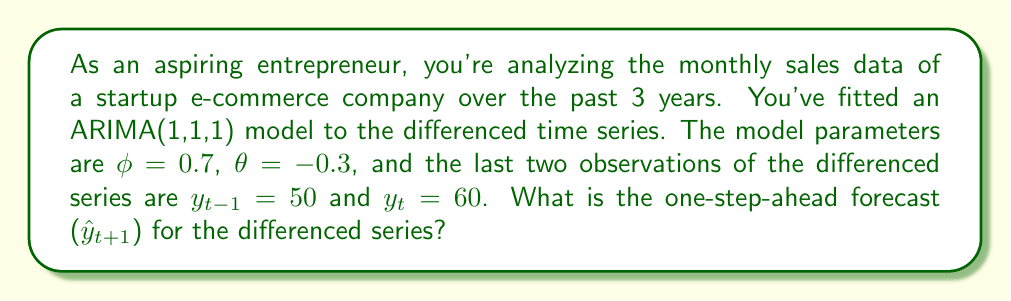Teach me how to tackle this problem. Let's approach this step-by-step:

1) The ARIMA(1,1,1) model for the differenced series can be written as:

   $$(1 - \phi B)(1 - B)Y_t = (1 + \theta B)\epsilon_t$$

   where $B$ is the backshift operator.

2) Expanding this, we get:

   $$Y_t - Y_{t-1} - \phi(Y_{t-1} - Y_{t-2}) = \epsilon_t + \theta\epsilon_{t-1}$$

3) Rearranging for forecasting:

   $$Y_t = Y_{t-1} + \phi(Y_{t-1} - Y_{t-2}) + \epsilon_t + \theta\epsilon_{t-1}$$

4) For one-step-ahead forecasting, we set future error terms to their expected value of 0:

   $$\hat{Y}_{t+1} = Y_t + \phi(Y_t - Y_{t-1}) + \theta\epsilon_t$$

5) We need to calculate $\epsilon_t$. We can do this using:

   $$\epsilon_t = Y_t - Y_{t-1} - \phi(Y_{t-1} - Y_{t-2}) - \theta\epsilon_{t-1}$$

6) We're given $y_t = 60$ and $y_{t-1} = 50$. We don't know $y_{t-2}$ or $\epsilon_{t-1}$, but we can approximate $\epsilon_t$ as:

   $$\epsilon_t \approx y_t - y_{t-1} - \phi(y_{t-1} - y_{t-1}) = 60 - 50 - 0.7(50 - 50) = 10$$

7) Now we can forecast:

   $$\hat{y}_{t+1} = y_t + \phi(y_t - y_{t-1}) + \theta\epsilon_t$$
   $$= 60 + 0.7(60 - 50) + (-0.3)(10)$$
   $$= 60 + 7 - 3$$
   $$= 64$$

Therefore, the one-step-ahead forecast for the differenced series is 64.
Answer: 64 